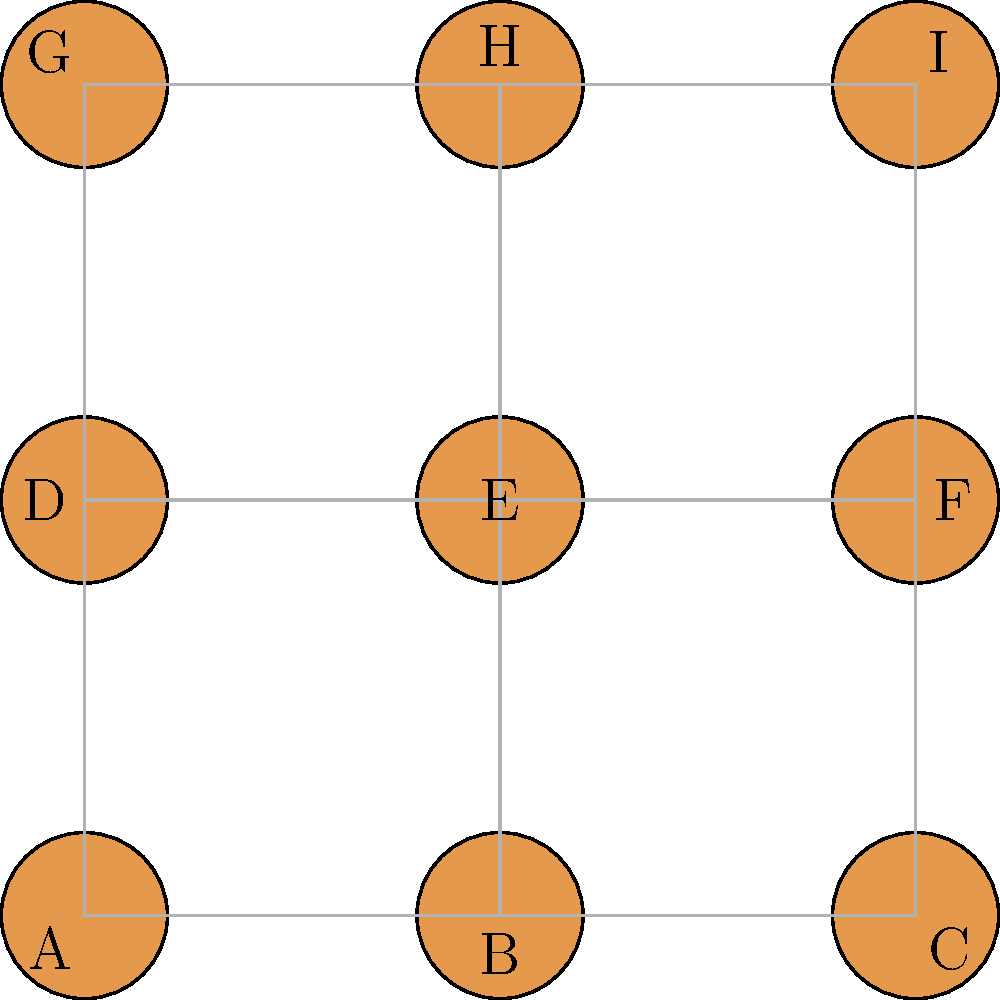In this neighborhood layout, each house is represented by a node, and connections between houses are shown by lines. Assuming that the number of direct connections to other houses influences property value, which house(s) would likely have the highest value, and how many direct connections does it have? To determine which house(s) would likely have the highest value, we need to count the number of direct connections for each house:

1. House A: 2 connections (B and D)
2. House B: 3 connections (A, C, and E)
3. House C: 2 connections (B and F)
4. House D: 3 connections (A, E, and G)
5. House E: 4 connections (B, D, F, and H)
6. House F: 3 connections (C, E, and I)
7. House G: 2 connections (D and H)
8. House H: 3 connections (E, G, and I)
9. House I: 2 connections (F and H)

From this analysis, we can see that House E has the highest number of direct connections with 4. This means it has the most immediate neighbors, which could potentially lead to the highest property value based on the given assumption.

It's worth noting that in real estate, many other factors influence property value, and this simplified model doesn't account for those. However, given the constraints of the question, House E would be considered the most valuable due to its central location and high connectivity.
Answer: House E, 4 connections 